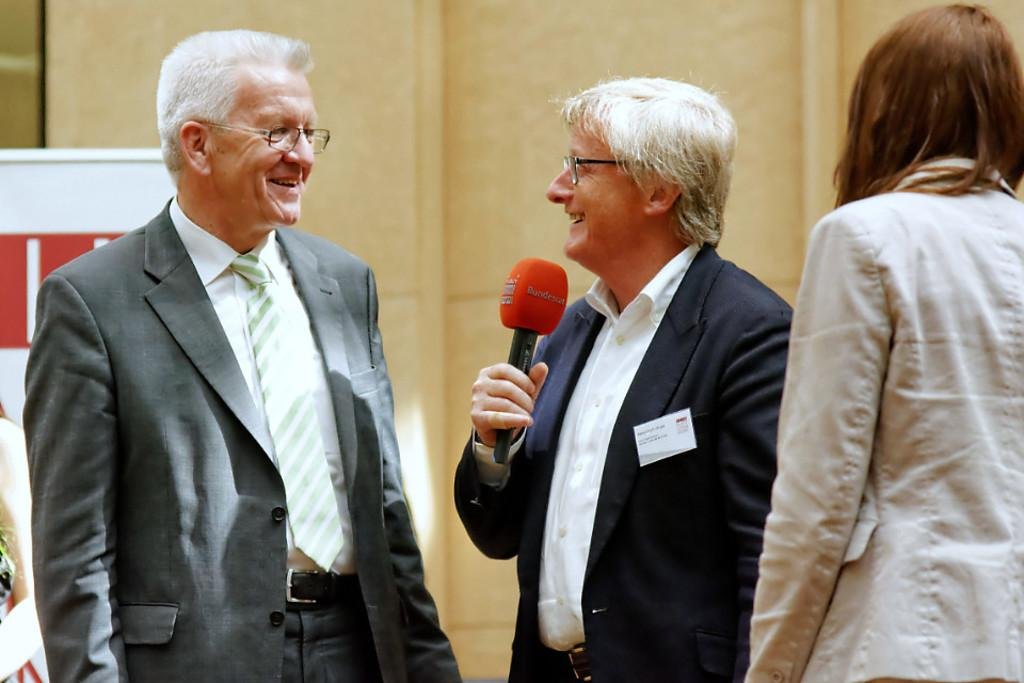How many people are present in the image? There are three people standing in the image. What is one of the people holding in their hand? One of the people is holding a microphone in their hand. Can you see a river flowing behind the people in the image? There is no river visible in the image. What type of jewel is being held by one of the people in the image? There is no jewel present in the image. 